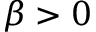Convert formula to latex. <formula><loc_0><loc_0><loc_500><loc_500>\beta > 0</formula> 